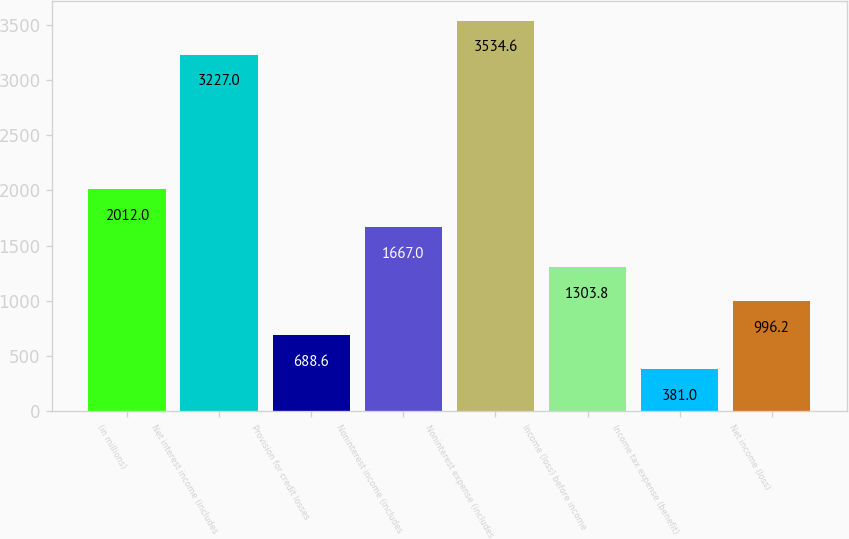<chart> <loc_0><loc_0><loc_500><loc_500><bar_chart><fcel>(in millions)<fcel>Net interest income (includes<fcel>Provision for credit losses<fcel>Noninterest income (includes<fcel>Noninterest expense (includes<fcel>Income (loss) before income<fcel>Income tax expense (benefit)<fcel>Net income (loss)<nl><fcel>2012<fcel>3227<fcel>688.6<fcel>1667<fcel>3534.6<fcel>1303.8<fcel>381<fcel>996.2<nl></chart> 